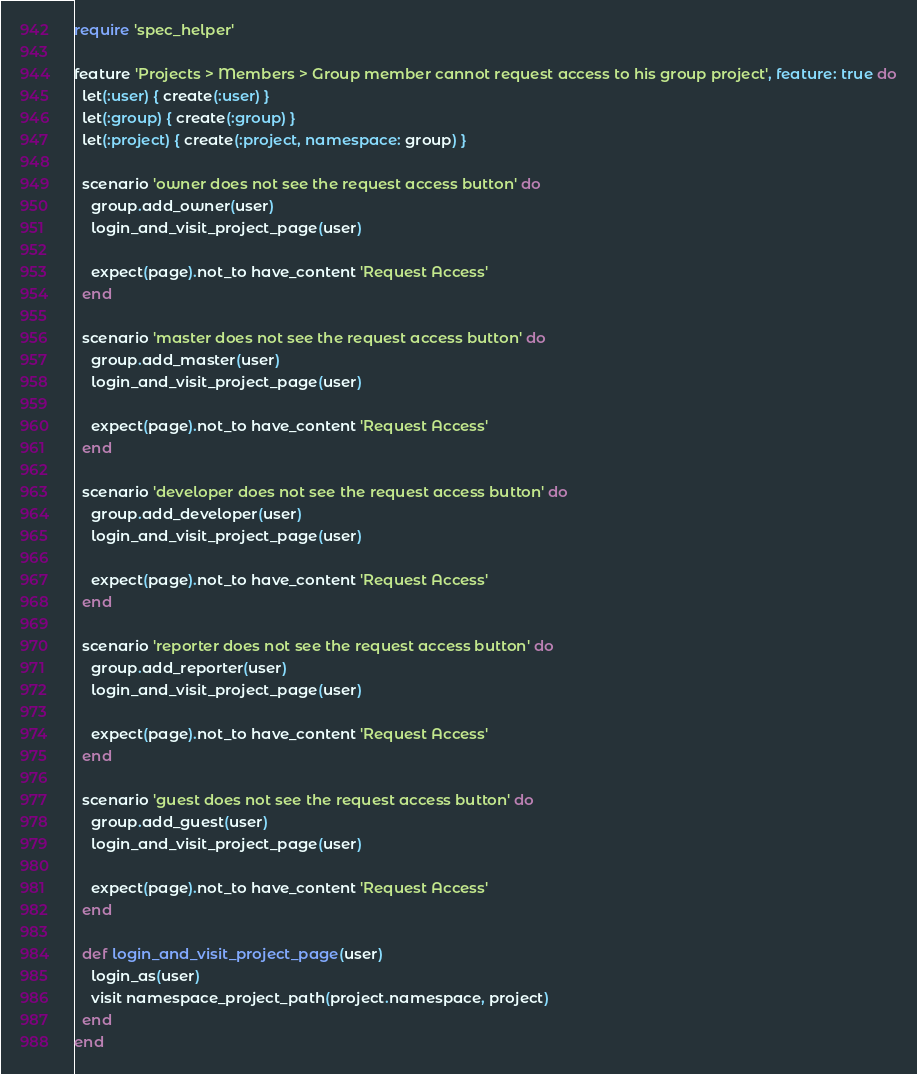<code> <loc_0><loc_0><loc_500><loc_500><_Ruby_>require 'spec_helper'

feature 'Projects > Members > Group member cannot request access to his group project', feature: true do
  let(:user) { create(:user) }
  let(:group) { create(:group) }
  let(:project) { create(:project, namespace: group) }

  scenario 'owner does not see the request access button' do
    group.add_owner(user)
    login_and_visit_project_page(user)

    expect(page).not_to have_content 'Request Access'
  end

  scenario 'master does not see the request access button' do
    group.add_master(user)
    login_and_visit_project_page(user)

    expect(page).not_to have_content 'Request Access'
  end

  scenario 'developer does not see the request access button' do
    group.add_developer(user)
    login_and_visit_project_page(user)

    expect(page).not_to have_content 'Request Access'
  end

  scenario 'reporter does not see the request access button' do
    group.add_reporter(user)
    login_and_visit_project_page(user)

    expect(page).not_to have_content 'Request Access'
  end

  scenario 'guest does not see the request access button' do
    group.add_guest(user)
    login_and_visit_project_page(user)

    expect(page).not_to have_content 'Request Access'
  end

  def login_and_visit_project_page(user)
    login_as(user)
    visit namespace_project_path(project.namespace, project)
  end
end
</code> 